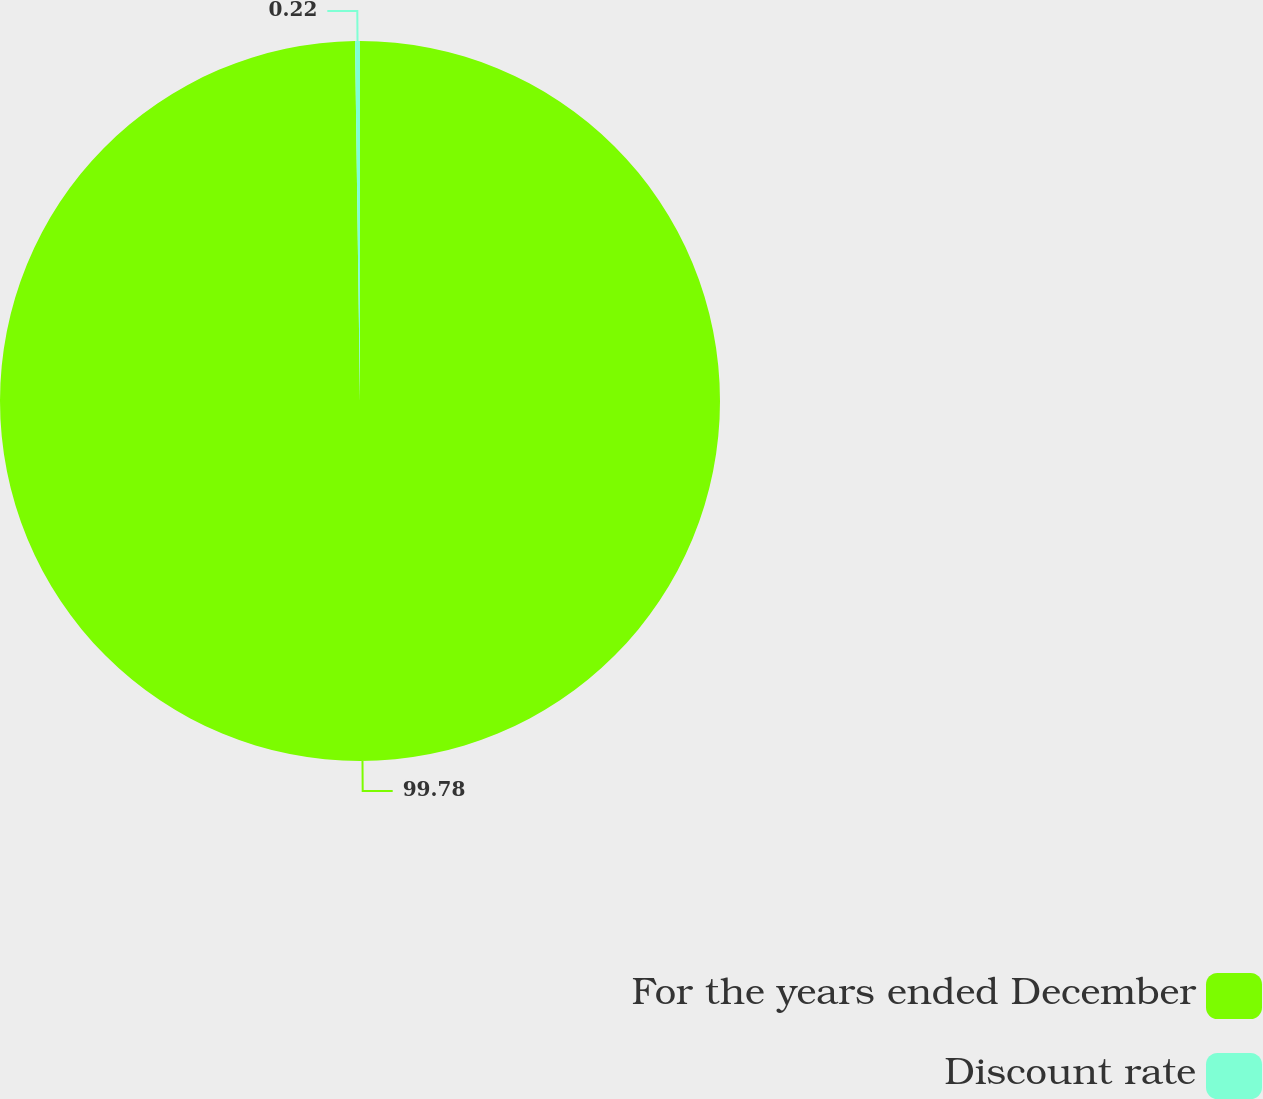<chart> <loc_0><loc_0><loc_500><loc_500><pie_chart><fcel>For the years ended December<fcel>Discount rate<nl><fcel>99.78%<fcel>0.22%<nl></chart> 